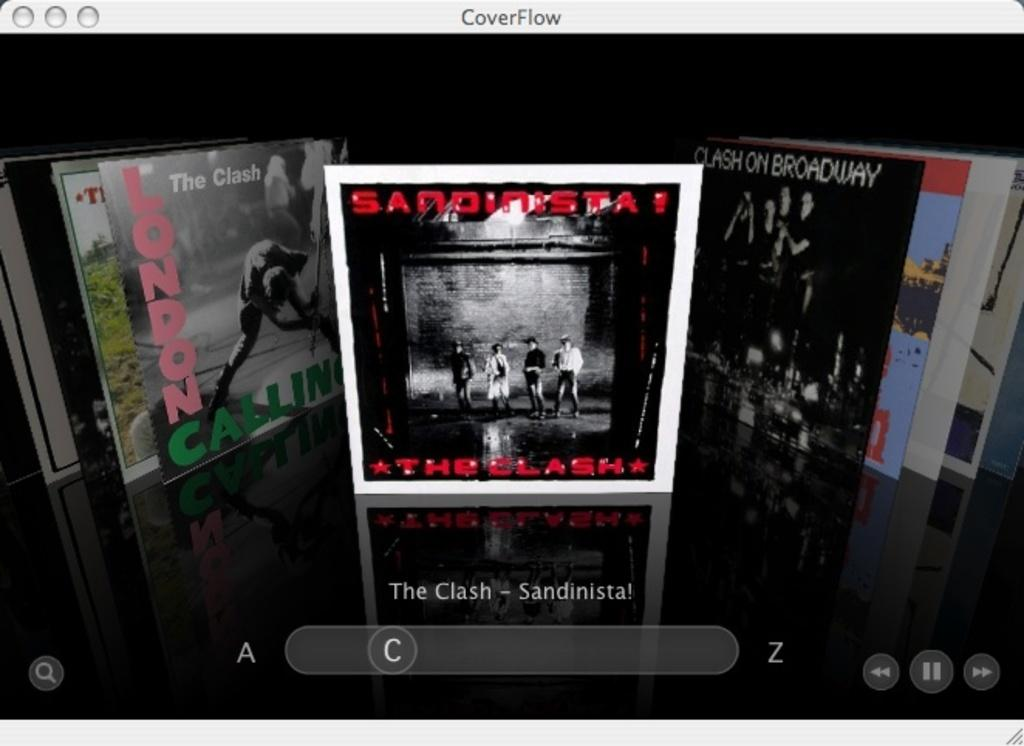<image>
Provide a brief description of the given image. The clash sandinista records including clash on broadway 